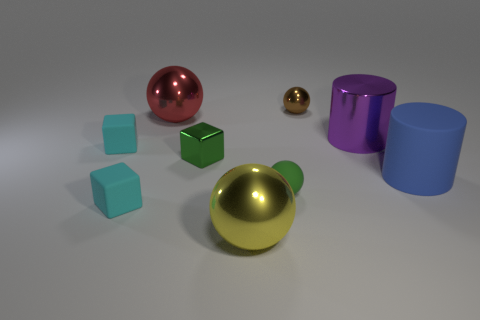There is a metal object that is the same color as the matte ball; what shape is it?
Your answer should be very brief. Cube. The cube that is the same color as the small rubber sphere is what size?
Keep it short and to the point. Small. There is a large object that is left of the tiny metal thing that is left of the tiny brown thing that is behind the large red thing; what is its shape?
Offer a very short reply. Sphere. How many things are green spheres or big purple cylinders that are behind the small green metallic block?
Your answer should be compact. 2. Does the cyan thing in front of the shiny block have the same shape as the tiny shiny thing in front of the large red ball?
Provide a short and direct response. Yes. How many objects are either large spheres or small brown things?
Ensure brevity in your answer.  3. Are any red rubber cubes visible?
Provide a short and direct response. No. Is the small sphere that is in front of the tiny brown thing made of the same material as the large red thing?
Provide a short and direct response. No. Is there a large metallic object that has the same shape as the tiny brown metallic object?
Offer a terse response. Yes. Is the number of big yellow objects that are behind the blue rubber cylinder the same as the number of large blue rubber blocks?
Offer a very short reply. Yes. 